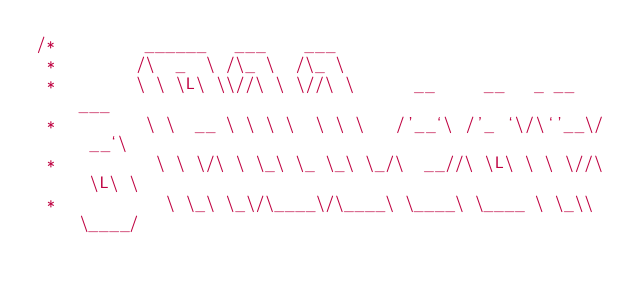<code> <loc_0><loc_0><loc_500><loc_500><_C_>/*         ______   ___    ___
 *        /\  _  \ /\_ \  /\_ \
 *        \ \ \L\ \\//\ \ \//\ \      __     __   _ __   ___
 *         \ \  __ \ \ \ \  \ \ \   /'__`\ /'_ `\/\`'__\/ __`\
 *          \ \ \/\ \ \_\ \_ \_\ \_/\  __//\ \L\ \ \ \//\ \L\ \
 *           \ \_\ \_\/\____\/\____\ \____\ \____ \ \_\\ \____/</code> 